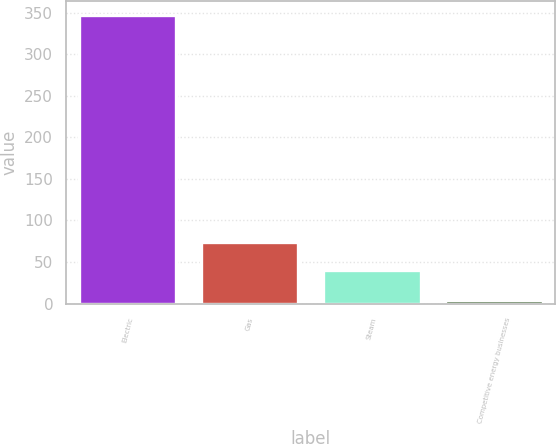<chart> <loc_0><loc_0><loc_500><loc_500><bar_chart><fcel>Electric<fcel>Gas<fcel>Steam<fcel>Competitive energy businesses<nl><fcel>347<fcel>74.3<fcel>40<fcel>4<nl></chart> 